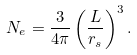Convert formula to latex. <formula><loc_0><loc_0><loc_500><loc_500>N _ { e } = \frac { 3 } { 4 \pi } \left ( \frac { L } { r _ { s } } \right ) ^ { 3 } .</formula> 